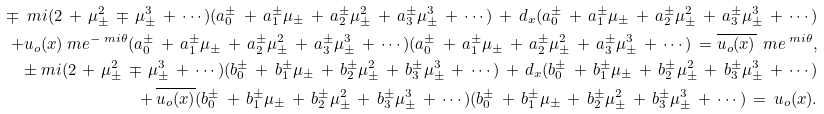<formula> <loc_0><loc_0><loc_500><loc_500>\mp \ m i ( 2 \, + \, \mu _ { \pm } ^ { 2 } \, \mp \, \mu _ { \pm } ^ { 3 } \, + \, \cdots ) ( a _ { 0 } ^ { \pm } \, + \, a _ { 1 } ^ { \pm } \mu _ { \pm } \, + \, a _ { 2 } ^ { \pm } \mu _ { \pm } ^ { 2 } \, + \, a _ { 3 } ^ { \pm } \mu _ { \pm } ^ { 3 } \, + \, \cdots ) \, + \, d _ { x } ( a _ { 0 } ^ { \pm } \, + \, a _ { 1 } ^ { \pm } \mu _ { \pm } \, + \, a _ { 2 } ^ { \pm } \mu _ { \pm } ^ { 2 } \, + \, a _ { 3 } ^ { \pm } \mu _ { \pm } ^ { 3 } \, + \, \cdots ) \\ + u _ { o } ( x ) \ m e ^ { - \ m i \theta } ( a _ { 0 } ^ { \pm } \, + \, a _ { 1 } ^ { \pm } \mu _ { \pm } \, + \, a _ { 2 } ^ { \pm } \mu _ { \pm } ^ { 2 } \, + \, a _ { 3 } ^ { \pm } \mu _ { \pm } ^ { 3 } \, + \, \cdots ) ( a _ { 0 } ^ { \pm } \, + \, a _ { 1 } ^ { \pm } \mu _ { \pm } \, + \, a _ { 2 } ^ { \pm } \mu _ { \pm } ^ { 2 } \, + \, a _ { 3 } ^ { \pm } \mu _ { \pm } ^ { 3 } \, + \, \cdots ) \, = \overline { u _ { o } ( x ) } \, \ m e ^ { \ m i \theta } , \\ \pm \ m i ( 2 \, + \, \mu _ { \pm } ^ { 2 } \, \mp \, \mu _ { \pm } ^ { 3 } \, + \, \cdots ) ( b _ { 0 } ^ { \pm } \, + \, b _ { 1 } ^ { \pm } \mu _ { \pm } \, + \, b _ { 2 } ^ { \pm } \mu _ { \pm } ^ { 2 } \, + \, b _ { 3 } ^ { \pm } \mu _ { \pm } ^ { 3 } \, + \, \cdots ) \, + \, d _ { x } ( b _ { 0 } ^ { \pm } \, + \, b _ { 1 } ^ { \pm } \mu _ { \pm } \, + \, b _ { 2 } ^ { \pm } \mu _ { \pm } ^ { 2 } \, + \, b _ { 3 } ^ { \pm } \mu _ { \pm } ^ { 3 } \, + \, \cdots ) \\ + \, \overline { u _ { o } ( x ) } ( b _ { 0 } ^ { \pm } \, + \, b _ { 1 } ^ { \pm } \mu _ { \pm } \, + \, b _ { 2 } ^ { \pm } \mu _ { \pm } ^ { 2 } \, + \, b _ { 3 } ^ { \pm } \mu _ { \pm } ^ { 3 } \, + \, \cdots ) ( b _ { 0 } ^ { \pm } \, + \, b _ { 1 } ^ { \pm } \mu _ { \pm } \, + \, b _ { 2 } ^ { \pm } \mu _ { \pm } ^ { 2 } \, + \, b _ { 3 } ^ { \pm } \mu _ { \pm } ^ { 3 } \, + \, \cdots ) \, = \, u _ { o } ( x ) .</formula> 